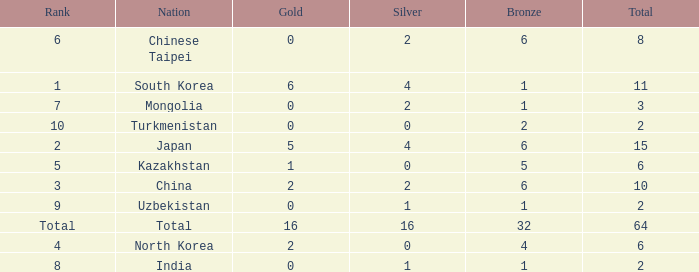What is the total Gold's less than 0? 0.0. 